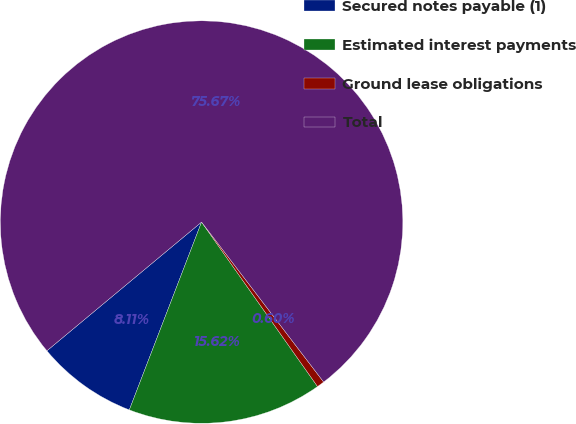Convert chart to OTSL. <chart><loc_0><loc_0><loc_500><loc_500><pie_chart><fcel>Secured notes payable (1)<fcel>Estimated interest payments<fcel>Ground lease obligations<fcel>Total<nl><fcel>8.11%<fcel>15.62%<fcel>0.6%<fcel>75.68%<nl></chart> 